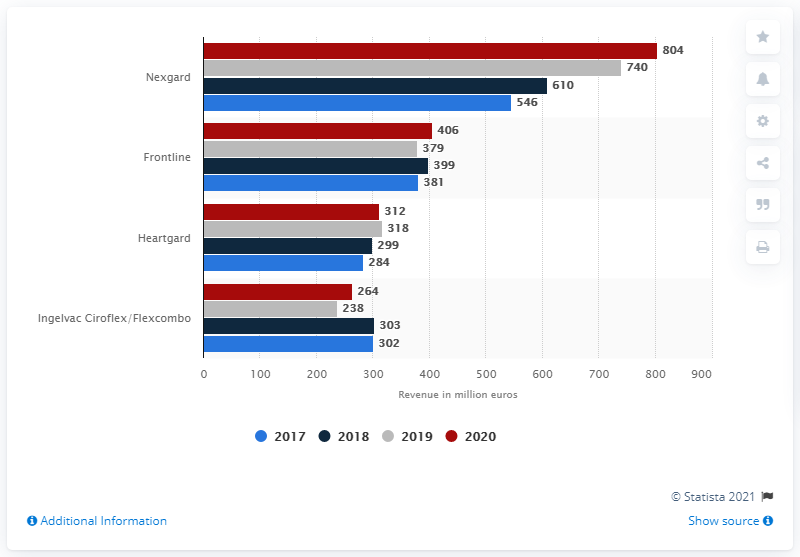List a handful of essential elements in this visual. In 2020, Nexgard was the top animal health product for Boehringer Ingelheim, a leading pharmaceutical company. Boehringer Ingelheim's top-selling animal health product in 2020 generated net sales of 804. 